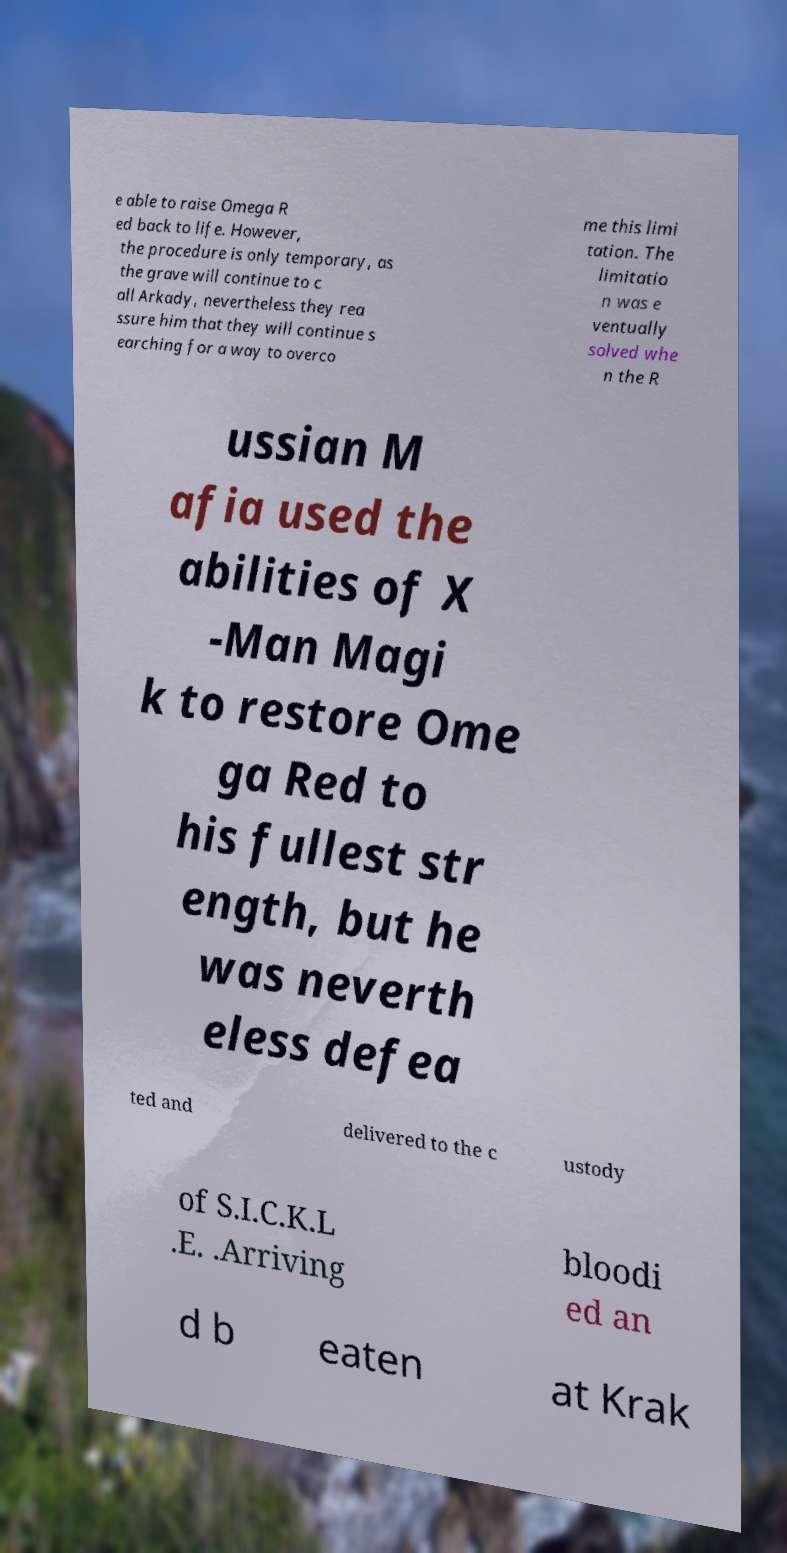Please read and relay the text visible in this image. What does it say? e able to raise Omega R ed back to life. However, the procedure is only temporary, as the grave will continue to c all Arkady, nevertheless they rea ssure him that they will continue s earching for a way to overco me this limi tation. The limitatio n was e ventually solved whe n the R ussian M afia used the abilities of X -Man Magi k to restore Ome ga Red to his fullest str ength, but he was neverth eless defea ted and delivered to the c ustody of S.I.C.K.L .E. .Arriving bloodi ed an d b eaten at Krak 